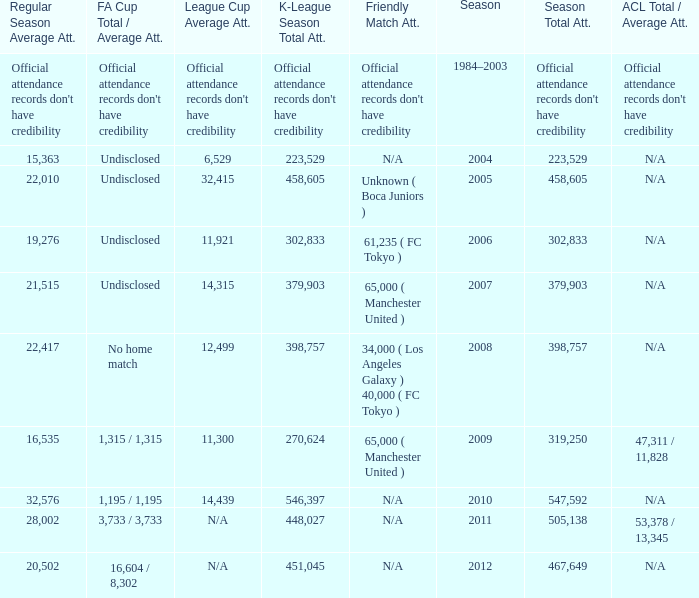What was attendance of the whole season when the average attendance for League Cup was 32,415? 458605.0. 